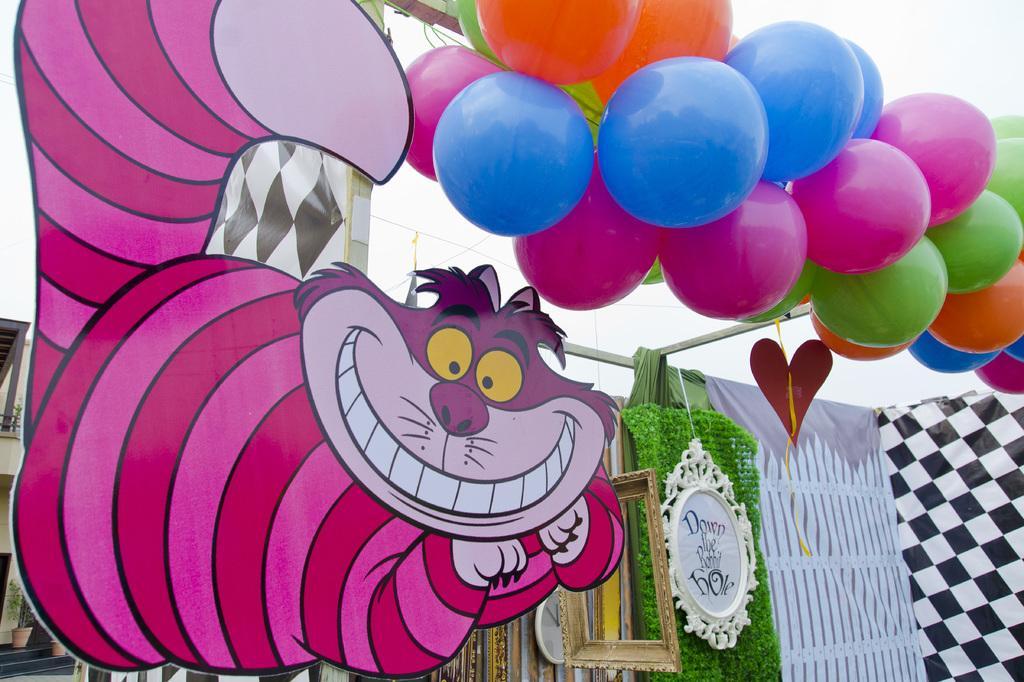Could you give a brief overview of what you see in this image? Here we can see animal board, balloons, clock and card. Left side of the image we can see a building and plants. 